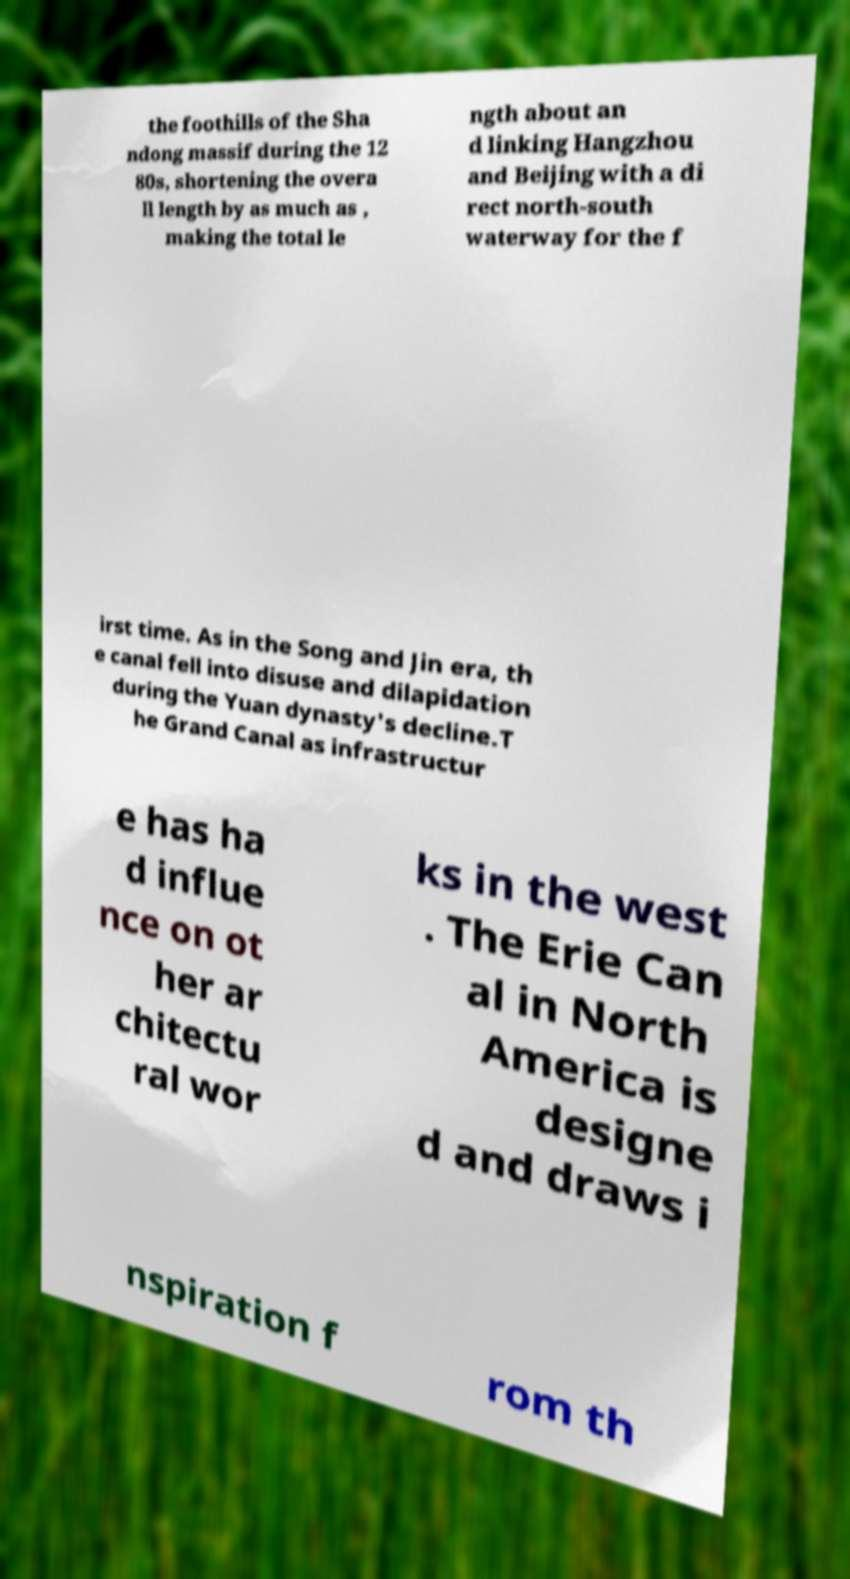What messages or text are displayed in this image? I need them in a readable, typed format. the foothills of the Sha ndong massif during the 12 80s, shortening the overa ll length by as much as , making the total le ngth about an d linking Hangzhou and Beijing with a di rect north-south waterway for the f irst time. As in the Song and Jin era, th e canal fell into disuse and dilapidation during the Yuan dynasty's decline.T he Grand Canal as infrastructur e has ha d influe nce on ot her ar chitectu ral wor ks in the west . The Erie Can al in North America is designe d and draws i nspiration f rom th 